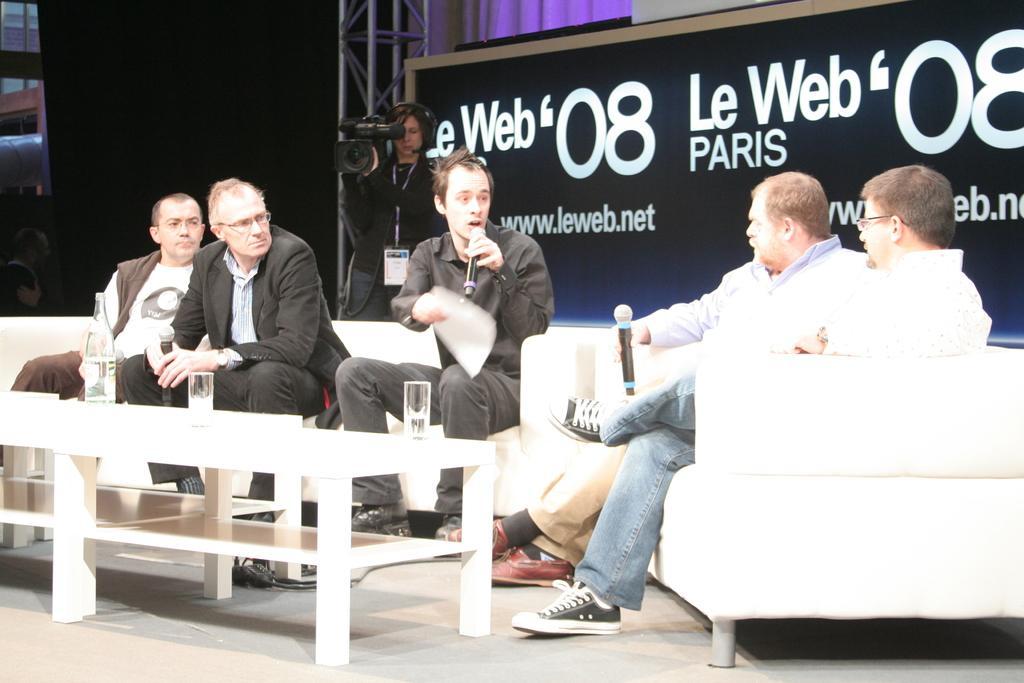Could you give a brief overview of what you see in this image? In this image I can see few people are sitting on the couch and few are holding mics. I can see glasses, bottles and few objects on the table. Back I can see a board and one person is standing and holding camera. Background is dark. 